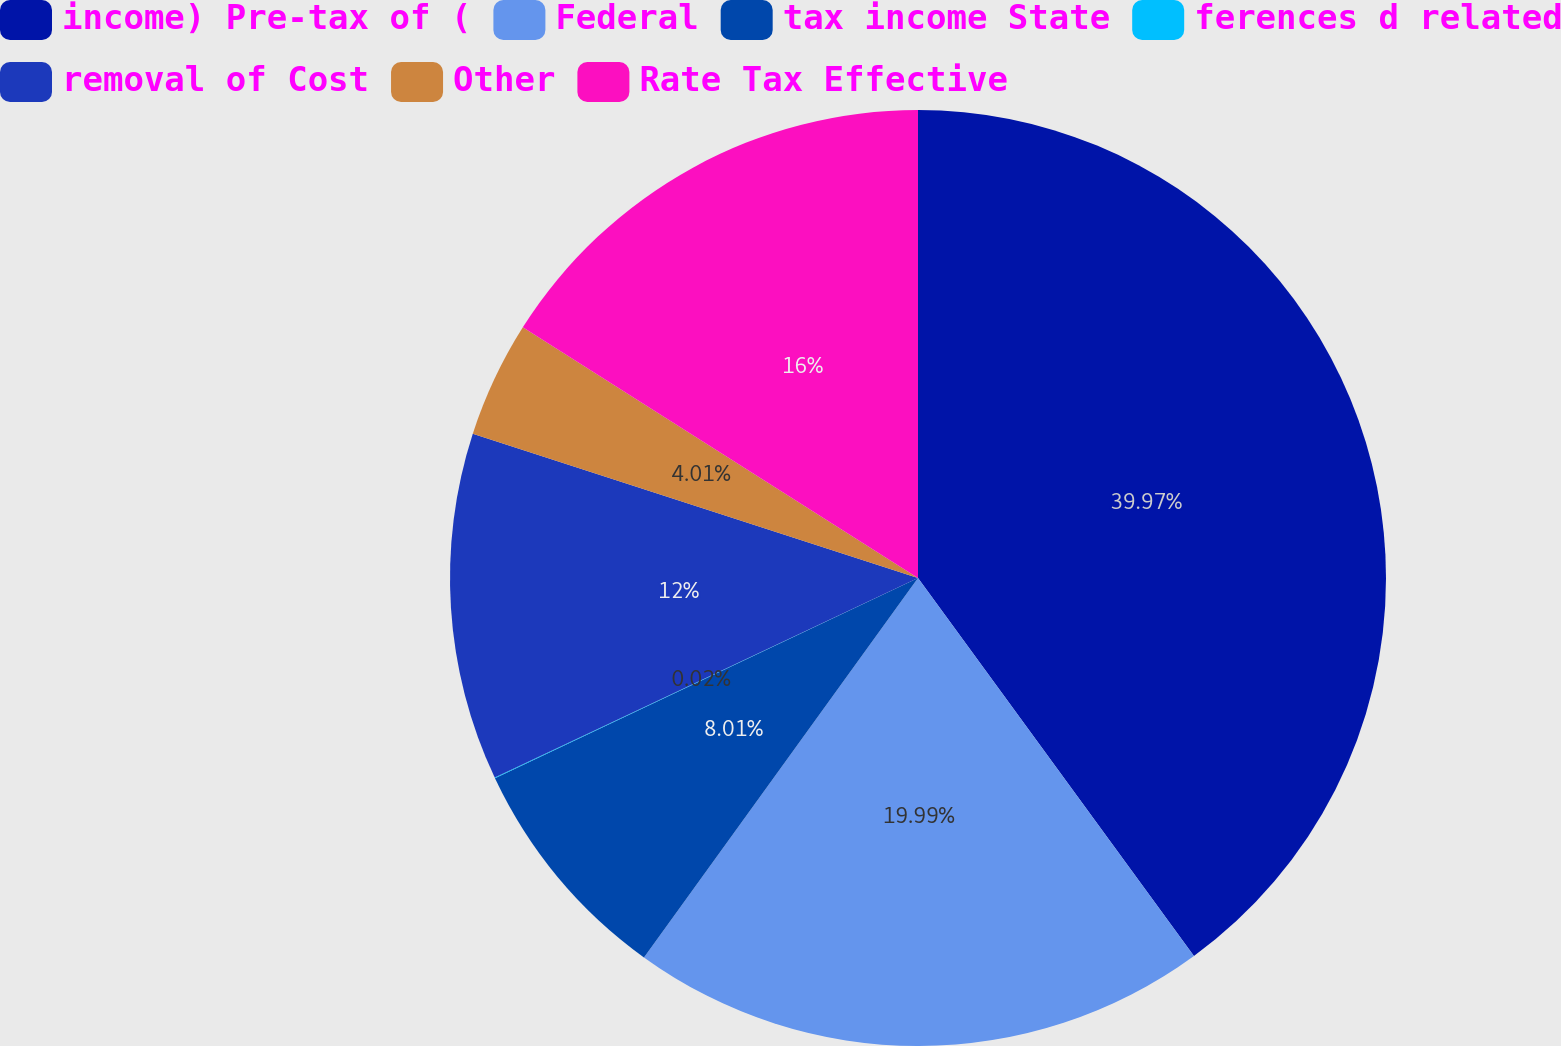Convert chart. <chart><loc_0><loc_0><loc_500><loc_500><pie_chart><fcel>income) Pre-tax of (<fcel>Federal<fcel>tax income State<fcel>ferences d related<fcel>removal of Cost<fcel>Other<fcel>Rate Tax Effective<nl><fcel>39.96%<fcel>19.99%<fcel>8.01%<fcel>0.02%<fcel>12.0%<fcel>4.01%<fcel>16.0%<nl></chart> 